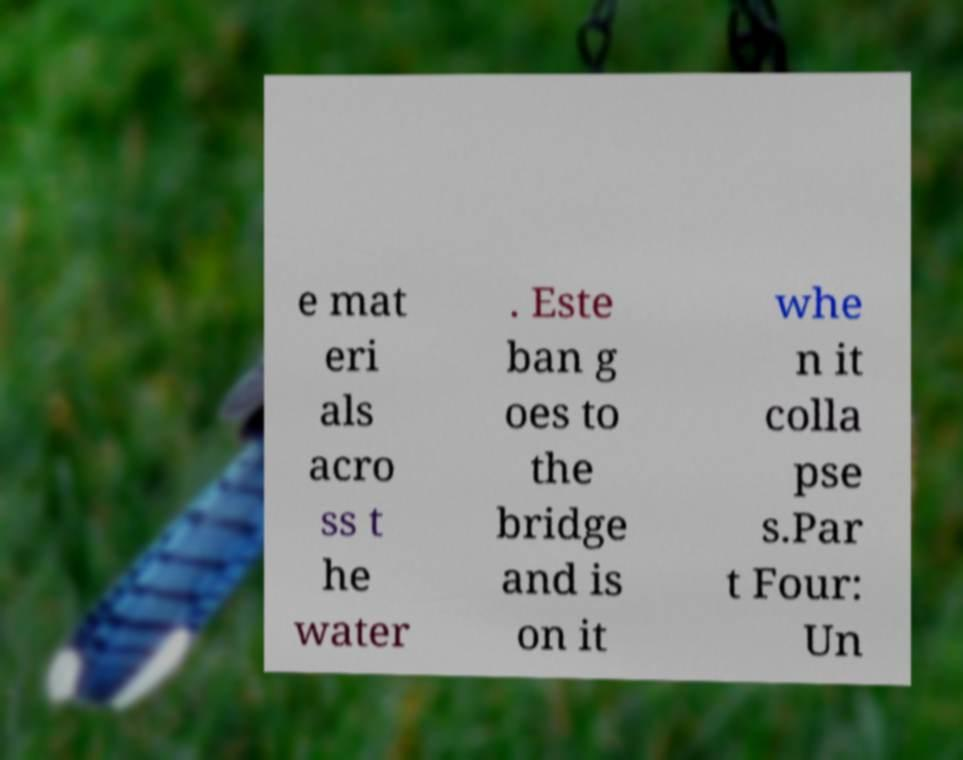Can you read and provide the text displayed in the image?This photo seems to have some interesting text. Can you extract and type it out for me? e mat eri als acro ss t he water . Este ban g oes to the bridge and is on it whe n it colla pse s.Par t Four: Un 